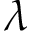<formula> <loc_0><loc_0><loc_500><loc_500>\lambda</formula> 